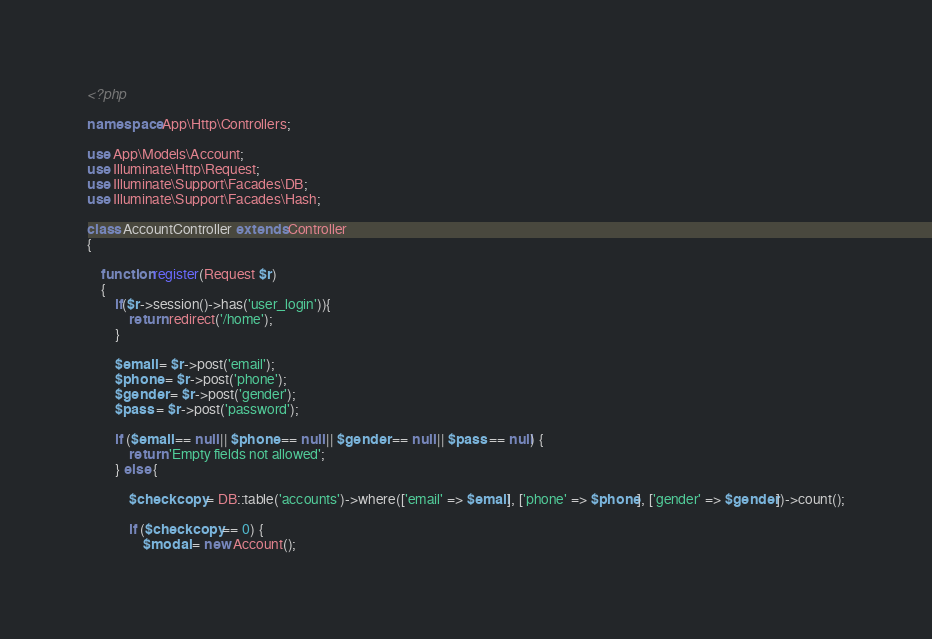Convert code to text. <code><loc_0><loc_0><loc_500><loc_500><_PHP_><?php

namespace App\Http\Controllers;

use App\Models\Account;
use Illuminate\Http\Request;
use Illuminate\Support\Facades\DB;
use Illuminate\Support\Facades\Hash;

class AccountController extends Controller
{

    function register(Request $r)
    {
        if($r->session()->has('user_login')){
            return redirect('/home');
        }

        $email = $r->post('email');
        $phone = $r->post('phone');
        $gender = $r->post('gender');
        $pass = $r->post('password');

        if ($email == null || $phone == null || $gender == null || $pass == null) {
            return 'Empty fields not allowed';
        } else {

            $checkcopy = DB::table('accounts')->where(['email' => $email], ['phone' => $phone], ['gender' => $gender])->count();

            if ($checkcopy == 0) {
                $modal = new Account();</code> 